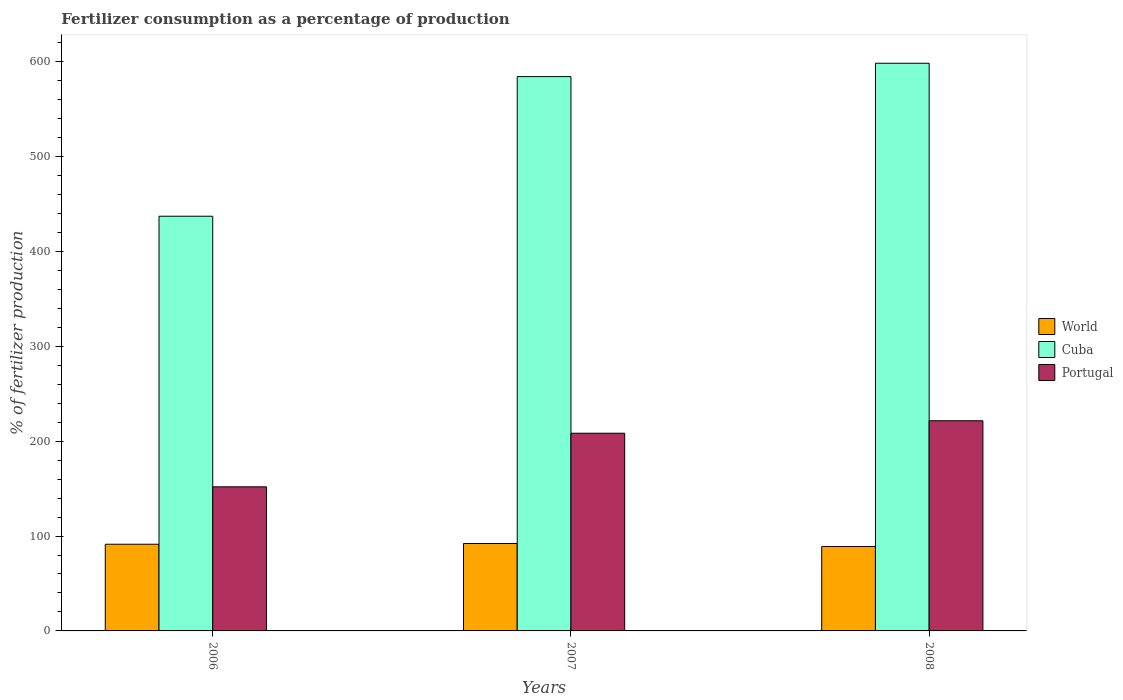How many bars are there on the 3rd tick from the left?
Provide a succinct answer. 3. What is the label of the 3rd group of bars from the left?
Keep it short and to the point. 2008. What is the percentage of fertilizers consumed in Cuba in 2006?
Provide a succinct answer. 436.98. Across all years, what is the maximum percentage of fertilizers consumed in Cuba?
Provide a succinct answer. 598.17. Across all years, what is the minimum percentage of fertilizers consumed in Cuba?
Provide a short and direct response. 436.98. In which year was the percentage of fertilizers consumed in Cuba maximum?
Provide a short and direct response. 2008. In which year was the percentage of fertilizers consumed in Cuba minimum?
Provide a short and direct response. 2006. What is the total percentage of fertilizers consumed in Cuba in the graph?
Your answer should be compact. 1619.26. What is the difference between the percentage of fertilizers consumed in Cuba in 2006 and that in 2007?
Make the answer very short. -147.13. What is the difference between the percentage of fertilizers consumed in Portugal in 2007 and the percentage of fertilizers consumed in Cuba in 2006?
Keep it short and to the point. -228.66. What is the average percentage of fertilizers consumed in Cuba per year?
Make the answer very short. 539.75. In the year 2006, what is the difference between the percentage of fertilizers consumed in World and percentage of fertilizers consumed in Cuba?
Keep it short and to the point. -345.64. In how many years, is the percentage of fertilizers consumed in World greater than 200 %?
Offer a terse response. 0. What is the ratio of the percentage of fertilizers consumed in Portugal in 2007 to that in 2008?
Provide a succinct answer. 0.94. Is the percentage of fertilizers consumed in Portugal in 2006 less than that in 2007?
Your answer should be very brief. Yes. What is the difference between the highest and the second highest percentage of fertilizers consumed in Portugal?
Your answer should be very brief. 13.13. What is the difference between the highest and the lowest percentage of fertilizers consumed in Portugal?
Offer a very short reply. 69.63. What does the 1st bar from the right in 2007 represents?
Offer a very short reply. Portugal. Are the values on the major ticks of Y-axis written in scientific E-notation?
Ensure brevity in your answer.  No. Does the graph contain any zero values?
Provide a short and direct response. No. How many legend labels are there?
Provide a short and direct response. 3. How are the legend labels stacked?
Keep it short and to the point. Vertical. What is the title of the graph?
Your response must be concise. Fertilizer consumption as a percentage of production. What is the label or title of the X-axis?
Your response must be concise. Years. What is the label or title of the Y-axis?
Your answer should be very brief. % of fertilizer production. What is the % of fertilizer production in World in 2006?
Your response must be concise. 91.34. What is the % of fertilizer production of Cuba in 2006?
Ensure brevity in your answer.  436.98. What is the % of fertilizer production in Portugal in 2006?
Provide a succinct answer. 151.82. What is the % of fertilizer production of World in 2007?
Keep it short and to the point. 92.12. What is the % of fertilizer production of Cuba in 2007?
Your response must be concise. 584.11. What is the % of fertilizer production of Portugal in 2007?
Ensure brevity in your answer.  208.32. What is the % of fertilizer production of World in 2008?
Ensure brevity in your answer.  88.93. What is the % of fertilizer production in Cuba in 2008?
Your response must be concise. 598.17. What is the % of fertilizer production of Portugal in 2008?
Provide a short and direct response. 221.45. Across all years, what is the maximum % of fertilizer production of World?
Your response must be concise. 92.12. Across all years, what is the maximum % of fertilizer production of Cuba?
Offer a terse response. 598.17. Across all years, what is the maximum % of fertilizer production of Portugal?
Provide a succinct answer. 221.45. Across all years, what is the minimum % of fertilizer production of World?
Give a very brief answer. 88.93. Across all years, what is the minimum % of fertilizer production in Cuba?
Your answer should be compact. 436.98. Across all years, what is the minimum % of fertilizer production of Portugal?
Offer a very short reply. 151.82. What is the total % of fertilizer production of World in the graph?
Offer a terse response. 272.4. What is the total % of fertilizer production of Cuba in the graph?
Ensure brevity in your answer.  1619.26. What is the total % of fertilizer production in Portugal in the graph?
Offer a terse response. 581.59. What is the difference between the % of fertilizer production of World in 2006 and that in 2007?
Your answer should be compact. -0.78. What is the difference between the % of fertilizer production of Cuba in 2006 and that in 2007?
Provide a short and direct response. -147.13. What is the difference between the % of fertilizer production in Portugal in 2006 and that in 2007?
Your answer should be very brief. -56.5. What is the difference between the % of fertilizer production in World in 2006 and that in 2008?
Provide a succinct answer. 2.41. What is the difference between the % of fertilizer production in Cuba in 2006 and that in 2008?
Your answer should be compact. -161.19. What is the difference between the % of fertilizer production in Portugal in 2006 and that in 2008?
Offer a very short reply. -69.63. What is the difference between the % of fertilizer production in World in 2007 and that in 2008?
Keep it short and to the point. 3.19. What is the difference between the % of fertilizer production in Cuba in 2007 and that in 2008?
Offer a terse response. -14.05. What is the difference between the % of fertilizer production in Portugal in 2007 and that in 2008?
Provide a succinct answer. -13.13. What is the difference between the % of fertilizer production of World in 2006 and the % of fertilizer production of Cuba in 2007?
Offer a very short reply. -492.77. What is the difference between the % of fertilizer production of World in 2006 and the % of fertilizer production of Portugal in 2007?
Offer a terse response. -116.98. What is the difference between the % of fertilizer production of Cuba in 2006 and the % of fertilizer production of Portugal in 2007?
Provide a short and direct response. 228.66. What is the difference between the % of fertilizer production of World in 2006 and the % of fertilizer production of Cuba in 2008?
Give a very brief answer. -506.83. What is the difference between the % of fertilizer production in World in 2006 and the % of fertilizer production in Portugal in 2008?
Make the answer very short. -130.11. What is the difference between the % of fertilizer production in Cuba in 2006 and the % of fertilizer production in Portugal in 2008?
Make the answer very short. 215.53. What is the difference between the % of fertilizer production of World in 2007 and the % of fertilizer production of Cuba in 2008?
Provide a succinct answer. -506.05. What is the difference between the % of fertilizer production of World in 2007 and the % of fertilizer production of Portugal in 2008?
Make the answer very short. -129.33. What is the difference between the % of fertilizer production of Cuba in 2007 and the % of fertilizer production of Portugal in 2008?
Your answer should be compact. 362.66. What is the average % of fertilizer production in World per year?
Ensure brevity in your answer.  90.8. What is the average % of fertilizer production of Cuba per year?
Your response must be concise. 539.75. What is the average % of fertilizer production of Portugal per year?
Offer a very short reply. 193.86. In the year 2006, what is the difference between the % of fertilizer production in World and % of fertilizer production in Cuba?
Offer a terse response. -345.64. In the year 2006, what is the difference between the % of fertilizer production in World and % of fertilizer production in Portugal?
Make the answer very short. -60.48. In the year 2006, what is the difference between the % of fertilizer production in Cuba and % of fertilizer production in Portugal?
Keep it short and to the point. 285.16. In the year 2007, what is the difference between the % of fertilizer production in World and % of fertilizer production in Cuba?
Your answer should be very brief. -491.99. In the year 2007, what is the difference between the % of fertilizer production of World and % of fertilizer production of Portugal?
Your response must be concise. -116.2. In the year 2007, what is the difference between the % of fertilizer production in Cuba and % of fertilizer production in Portugal?
Provide a short and direct response. 375.79. In the year 2008, what is the difference between the % of fertilizer production of World and % of fertilizer production of Cuba?
Keep it short and to the point. -509.24. In the year 2008, what is the difference between the % of fertilizer production in World and % of fertilizer production in Portugal?
Provide a short and direct response. -132.52. In the year 2008, what is the difference between the % of fertilizer production of Cuba and % of fertilizer production of Portugal?
Offer a terse response. 376.72. What is the ratio of the % of fertilizer production of World in 2006 to that in 2007?
Keep it short and to the point. 0.99. What is the ratio of the % of fertilizer production of Cuba in 2006 to that in 2007?
Provide a succinct answer. 0.75. What is the ratio of the % of fertilizer production in Portugal in 2006 to that in 2007?
Offer a very short reply. 0.73. What is the ratio of the % of fertilizer production of World in 2006 to that in 2008?
Provide a short and direct response. 1.03. What is the ratio of the % of fertilizer production in Cuba in 2006 to that in 2008?
Give a very brief answer. 0.73. What is the ratio of the % of fertilizer production in Portugal in 2006 to that in 2008?
Keep it short and to the point. 0.69. What is the ratio of the % of fertilizer production of World in 2007 to that in 2008?
Your response must be concise. 1.04. What is the ratio of the % of fertilizer production in Cuba in 2007 to that in 2008?
Your answer should be very brief. 0.98. What is the ratio of the % of fertilizer production in Portugal in 2007 to that in 2008?
Your answer should be compact. 0.94. What is the difference between the highest and the second highest % of fertilizer production of World?
Your answer should be compact. 0.78. What is the difference between the highest and the second highest % of fertilizer production of Cuba?
Keep it short and to the point. 14.05. What is the difference between the highest and the second highest % of fertilizer production of Portugal?
Your answer should be compact. 13.13. What is the difference between the highest and the lowest % of fertilizer production of World?
Make the answer very short. 3.19. What is the difference between the highest and the lowest % of fertilizer production in Cuba?
Make the answer very short. 161.19. What is the difference between the highest and the lowest % of fertilizer production in Portugal?
Your response must be concise. 69.63. 